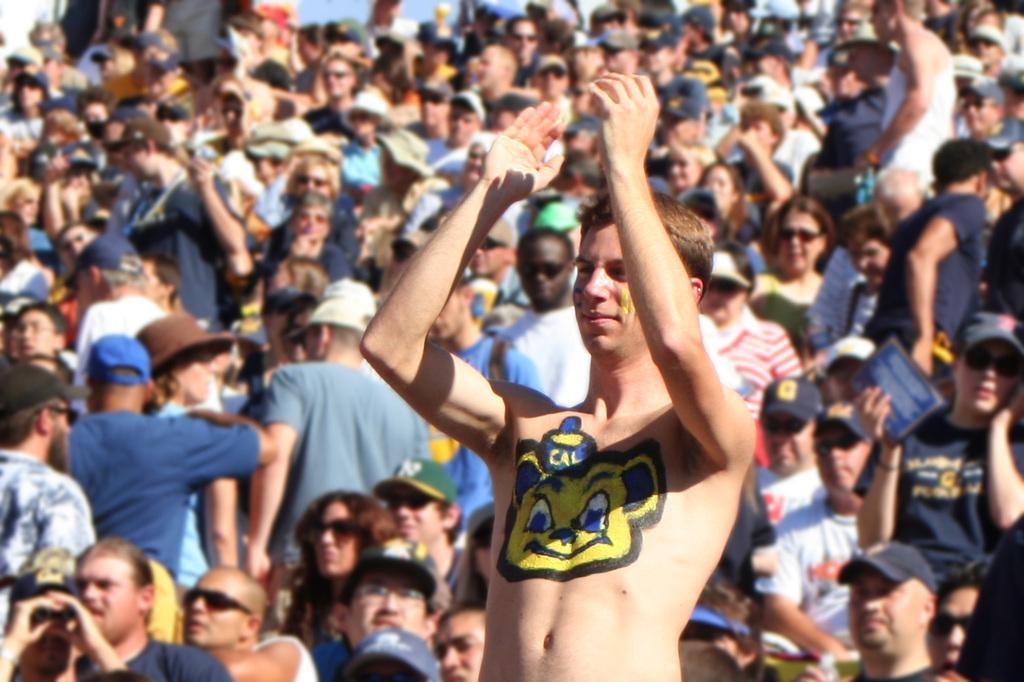How would you summarize this image in a sentence or two? In this image I can see a person with some painting on the chest. In the background, I can see a group of people. 